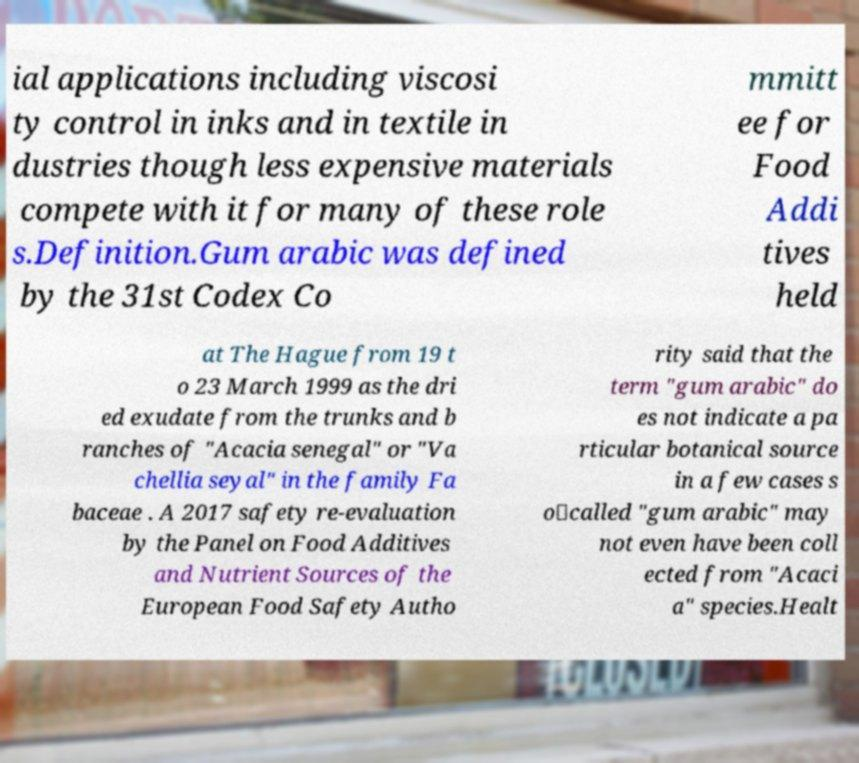Could you extract and type out the text from this image? ial applications including viscosi ty control in inks and in textile in dustries though less expensive materials compete with it for many of these role s.Definition.Gum arabic was defined by the 31st Codex Co mmitt ee for Food Addi tives held at The Hague from 19 t o 23 March 1999 as the dri ed exudate from the trunks and b ranches of "Acacia senegal" or "Va chellia seyal" in the family Fa baceae . A 2017 safety re-evaluation by the Panel on Food Additives and Nutrient Sources of the European Food Safety Autho rity said that the term "gum arabic" do es not indicate a pa rticular botanical source in a few cases s o‐called "gum arabic" may not even have been coll ected from "Acaci a" species.Healt 